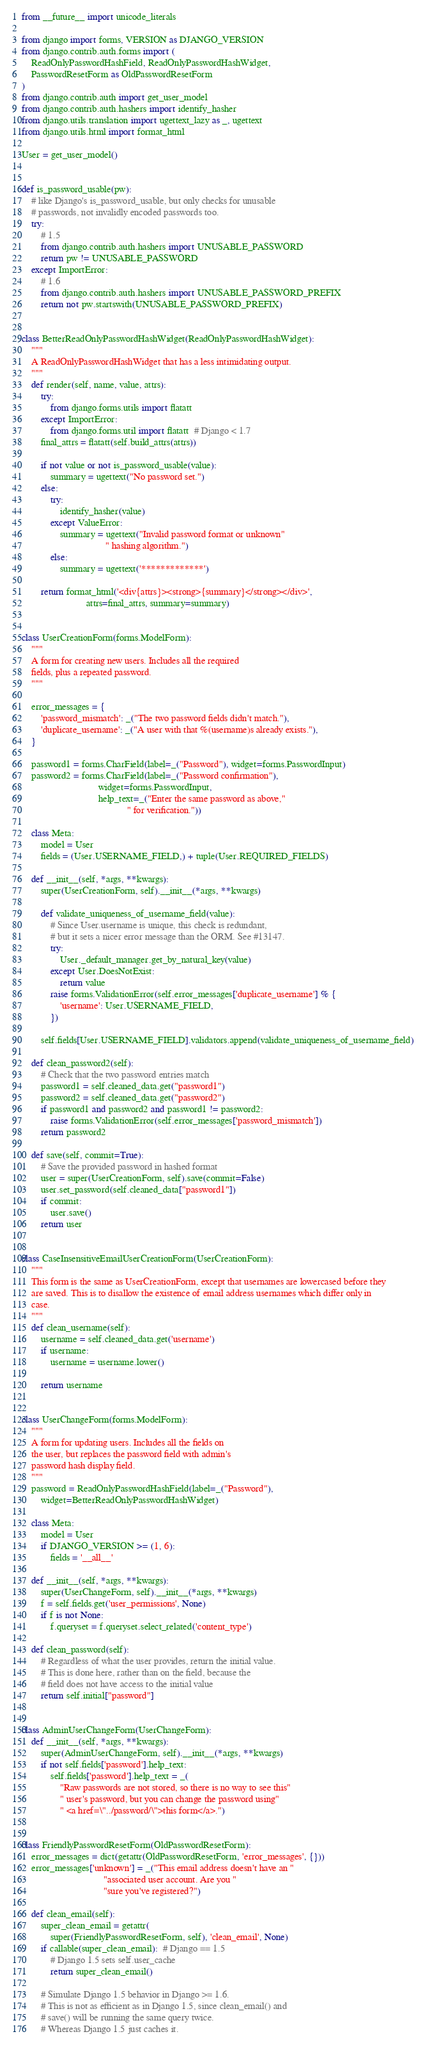<code> <loc_0><loc_0><loc_500><loc_500><_Python_>from __future__ import unicode_literals

from django import forms, VERSION as DJANGO_VERSION
from django.contrib.auth.forms import (
    ReadOnlyPasswordHashField, ReadOnlyPasswordHashWidget,
    PasswordResetForm as OldPasswordResetForm
)
from django.contrib.auth import get_user_model
from django.contrib.auth.hashers import identify_hasher
from django.utils.translation import ugettext_lazy as _, ugettext
from django.utils.html import format_html

User = get_user_model()


def is_password_usable(pw):
    # like Django's is_password_usable, but only checks for unusable
    # passwords, not invalidly encoded passwords too.
    try:
        # 1.5
        from django.contrib.auth.hashers import UNUSABLE_PASSWORD
        return pw != UNUSABLE_PASSWORD
    except ImportError:
        # 1.6
        from django.contrib.auth.hashers import UNUSABLE_PASSWORD_PREFIX
        return not pw.startswith(UNUSABLE_PASSWORD_PREFIX)


class BetterReadOnlyPasswordHashWidget(ReadOnlyPasswordHashWidget):
    """
    A ReadOnlyPasswordHashWidget that has a less intimidating output.
    """
    def render(self, name, value, attrs):
        try:
            from django.forms.utils import flatatt
        except ImportError:
            from django.forms.util import flatatt  # Django < 1.7
        final_attrs = flatatt(self.build_attrs(attrs))

        if not value or not is_password_usable(value):
            summary = ugettext("No password set.")
        else:
            try:
                identify_hasher(value)
            except ValueError:
                summary = ugettext("Invalid password format or unknown"
                                   " hashing algorithm.")
            else:
                summary = ugettext('*************')

        return format_html('<div{attrs}><strong>{summary}</strong></div>',
                           attrs=final_attrs, summary=summary)


class UserCreationForm(forms.ModelForm):
    """
    A form for creating new users. Includes all the required
    fields, plus a repeated password.
    """

    error_messages = {
        'password_mismatch': _("The two password fields didn't match."),
        'duplicate_username': _("A user with that %(username)s already exists."),
    }

    password1 = forms.CharField(label=_("Password"), widget=forms.PasswordInput)
    password2 = forms.CharField(label=_("Password confirmation"),
                                widget=forms.PasswordInput,
                                help_text=_("Enter the same password as above,"
                                            " for verification."))

    class Meta:
        model = User
        fields = (User.USERNAME_FIELD,) + tuple(User.REQUIRED_FIELDS)

    def __init__(self, *args, **kwargs):
        super(UserCreationForm, self).__init__(*args, **kwargs)

        def validate_uniqueness_of_username_field(value):
            # Since User.username is unique, this check is redundant,
            # but it sets a nicer error message than the ORM. See #13147.
            try:
                User._default_manager.get_by_natural_key(value)
            except User.DoesNotExist:
                return value
            raise forms.ValidationError(self.error_messages['duplicate_username'] % {
                'username': User.USERNAME_FIELD,
            })

        self.fields[User.USERNAME_FIELD].validators.append(validate_uniqueness_of_username_field)

    def clean_password2(self):
        # Check that the two password entries match
        password1 = self.cleaned_data.get("password1")
        password2 = self.cleaned_data.get("password2")
        if password1 and password2 and password1 != password2:
            raise forms.ValidationError(self.error_messages['password_mismatch'])
        return password2

    def save(self, commit=True):
        # Save the provided password in hashed format
        user = super(UserCreationForm, self).save(commit=False)
        user.set_password(self.cleaned_data["password1"])
        if commit:
            user.save()
        return user


class CaseInsensitiveEmailUserCreationForm(UserCreationForm):
    """
    This form is the same as UserCreationForm, except that usernames are lowercased before they
    are saved. This is to disallow the existence of email address usernames which differ only in
    case.
    """
    def clean_username(self):
        username = self.cleaned_data.get('username')
        if username:
            username = username.lower()

        return username


class UserChangeForm(forms.ModelForm):
    """
    A form for updating users. Includes all the fields on
    the user, but replaces the password field with admin's
    password hash display field.
    """
    password = ReadOnlyPasswordHashField(label=_("Password"),
        widget=BetterReadOnlyPasswordHashWidget)

    class Meta:
        model = User
        if DJANGO_VERSION >= (1, 6):
            fields = '__all__'

    def __init__(self, *args, **kwargs):
        super(UserChangeForm, self).__init__(*args, **kwargs)
        f = self.fields.get('user_permissions', None)
        if f is not None:
            f.queryset = f.queryset.select_related('content_type')

    def clean_password(self):
        # Regardless of what the user provides, return the initial value.
        # This is done here, rather than on the field, because the
        # field does not have access to the initial value
        return self.initial["password"]


class AdminUserChangeForm(UserChangeForm):
    def __init__(self, *args, **kwargs):
        super(AdminUserChangeForm, self).__init__(*args, **kwargs)
        if not self.fields['password'].help_text:
            self.fields['password'].help_text = _(
                "Raw passwords are not stored, so there is no way to see this"
                " user's password, but you can change the password using"
                " <a href=\"../password/\">this form</a>.")


class FriendlyPasswordResetForm(OldPasswordResetForm):
    error_messages = dict(getattr(OldPasswordResetForm, 'error_messages', {}))
    error_messages['unknown'] = _("This email address doesn't have an "
                                  "associated user account. Are you "
                                  "sure you've registered?")

    def clean_email(self):
        super_clean_email = getattr(
            super(FriendlyPasswordResetForm, self), 'clean_email', None)
        if callable(super_clean_email):  # Django == 1.5
            # Django 1.5 sets self.user_cache
            return super_clean_email()

        # Simulate Django 1.5 behavior in Django >= 1.6.
        # This is not as efficient as in Django 1.5, since clean_email() and
        # save() will be running the same query twice.
        # Whereas Django 1.5 just caches it.</code> 